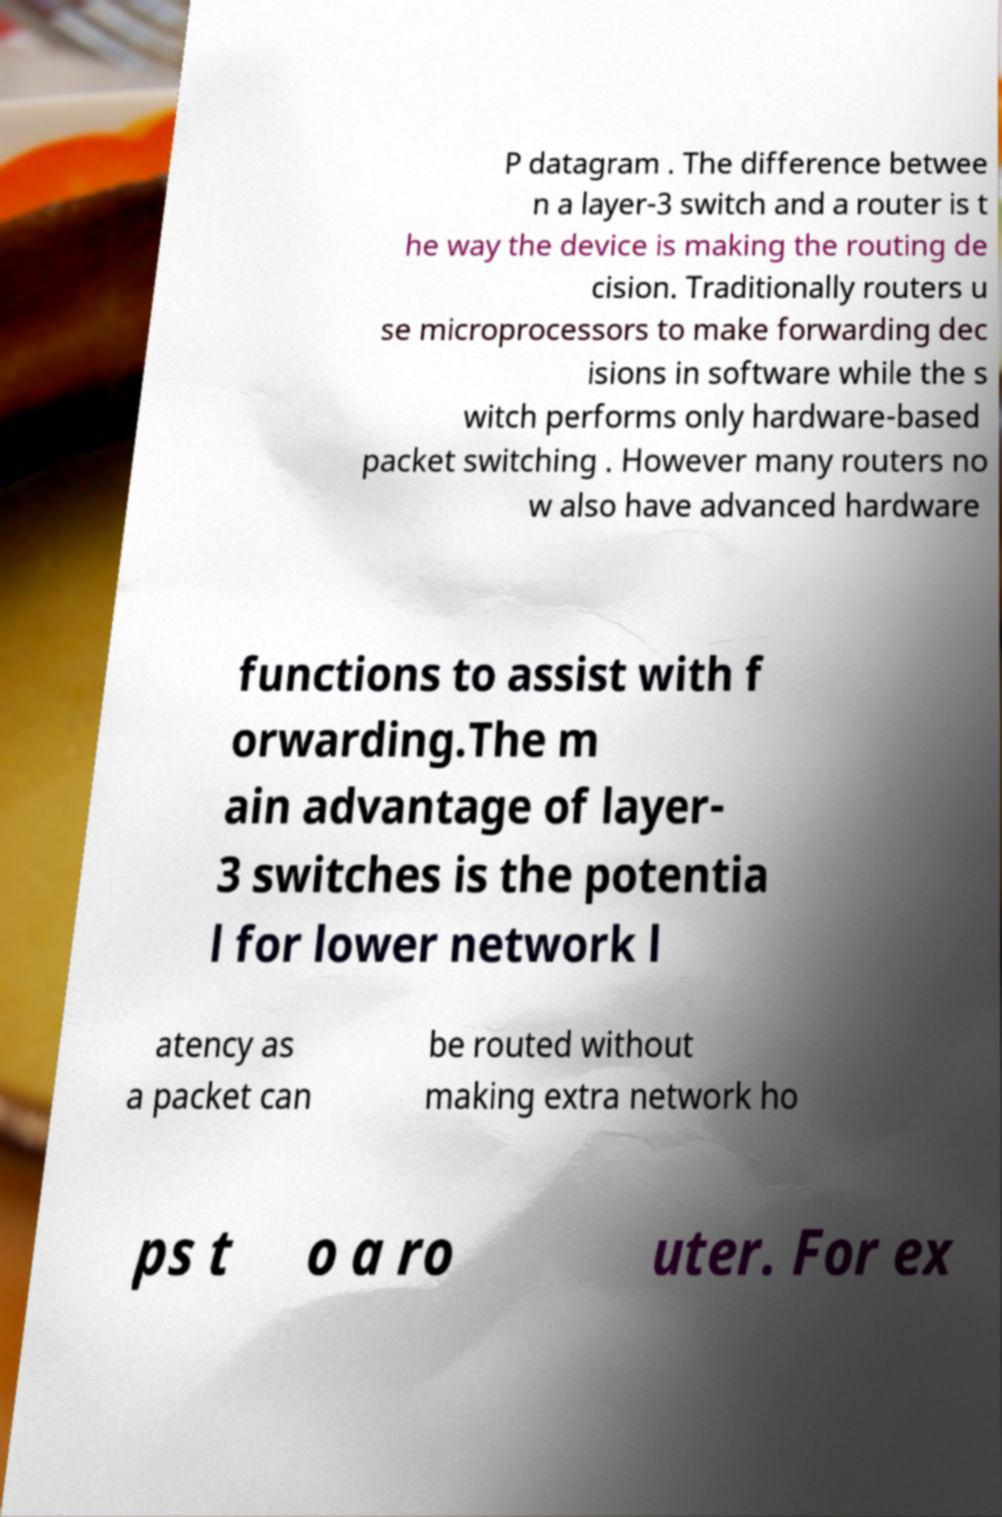Could you assist in decoding the text presented in this image and type it out clearly? P datagram . The difference betwee n a layer-3 switch and a router is t he way the device is making the routing de cision. Traditionally routers u se microprocessors to make forwarding dec isions in software while the s witch performs only hardware-based packet switching . However many routers no w also have advanced hardware functions to assist with f orwarding.The m ain advantage of layer- 3 switches is the potentia l for lower network l atency as a packet can be routed without making extra network ho ps t o a ro uter. For ex 